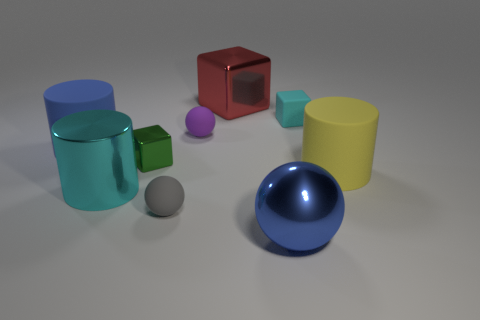Subtract all small spheres. How many spheres are left? 1 Subtract 1 blocks. How many blocks are left? 2 Add 1 gray balls. How many objects exist? 10 Subtract all cubes. How many objects are left? 6 Subtract 0 blue blocks. How many objects are left? 9 Subtract all large cyan things. Subtract all matte spheres. How many objects are left? 6 Add 2 large red metal blocks. How many large red metal blocks are left? 3 Add 5 big blue metal spheres. How many big blue metal spheres exist? 6 